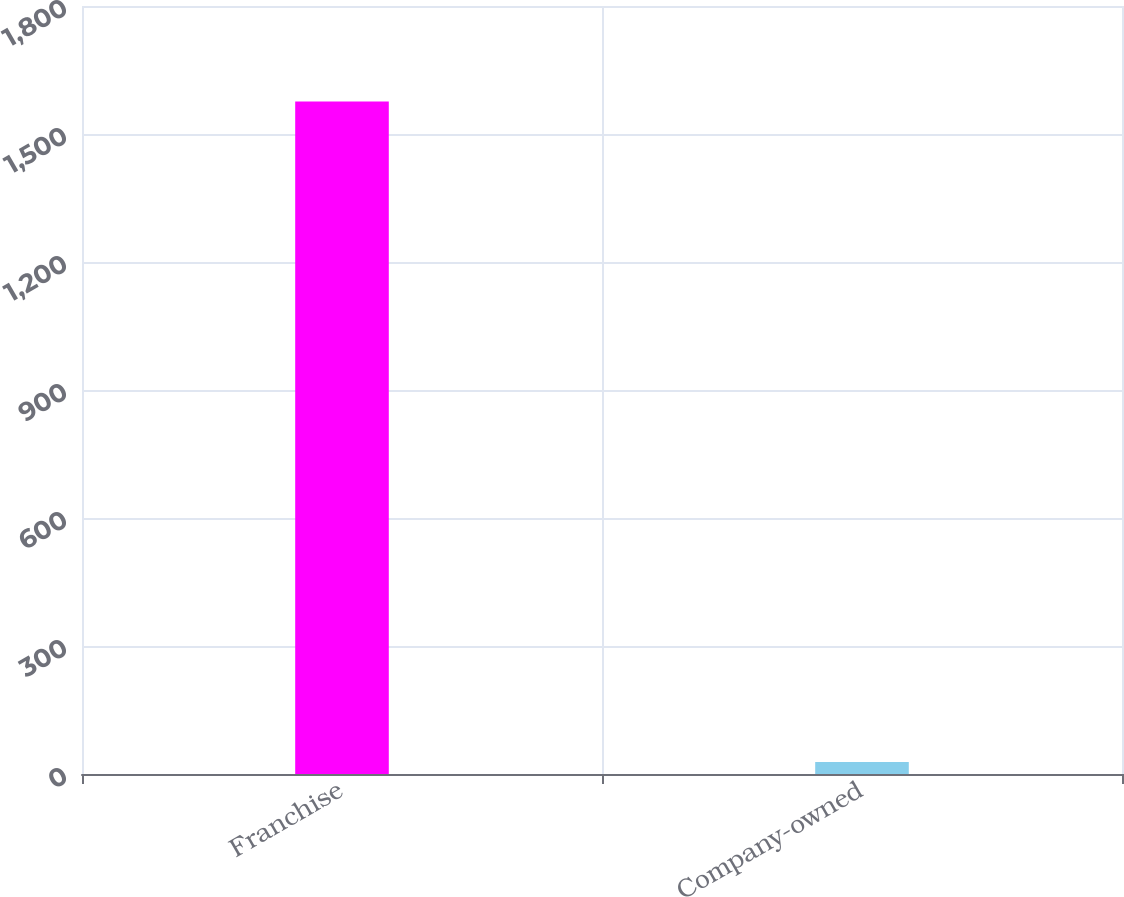Convert chart to OTSL. <chart><loc_0><loc_0><loc_500><loc_500><bar_chart><fcel>Franchise<fcel>Company-owned<nl><fcel>1576<fcel>28<nl></chart> 